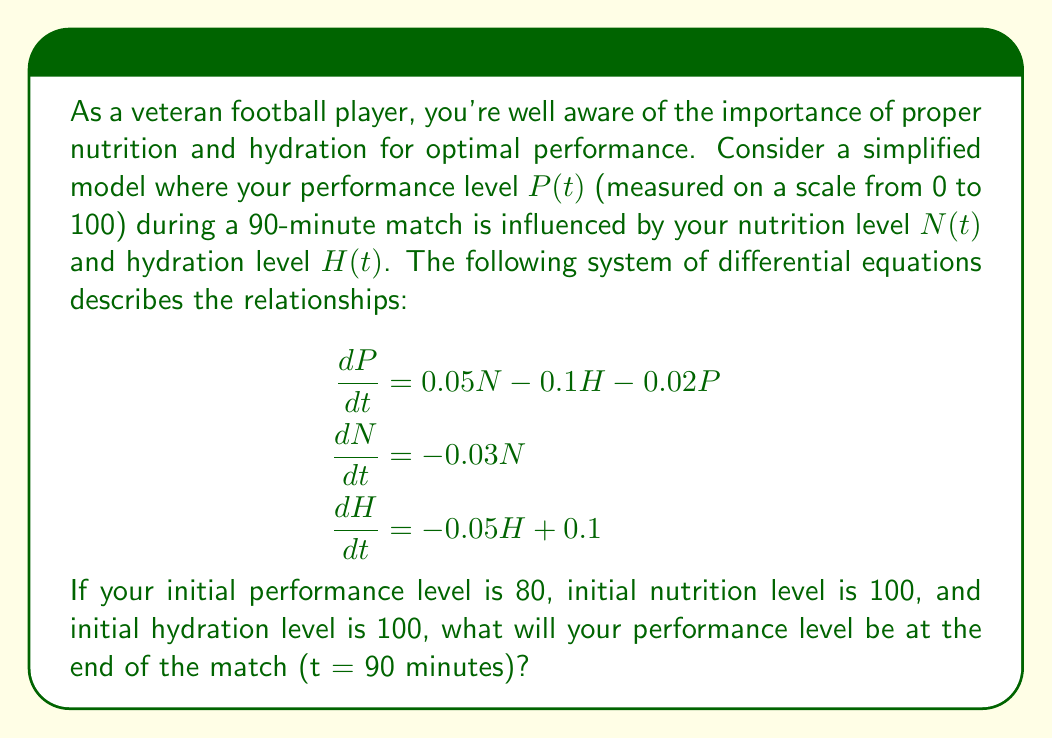What is the answer to this math problem? To solve this problem, we need to use numerical methods to approximate the solution of the system of differential equations. We'll use the Euler method with a step size of 5 minutes.

1) First, let's define our initial conditions:
   $P(0) = 80$, $N(0) = 100$, $H(0) = 100$

2) We'll use the Euler method formula:
   $y_{n+1} = y_n + h \cdot f(t_n, y_n)$
   where $h$ is the step size (5 minutes in our case)

3) For each 5-minute interval, we'll calculate:
   $P_{n+1} = P_n + 5 \cdot (0.05N_n - 0.1H_n - 0.02P_n)$
   $N_{n+1} = N_n + 5 \cdot (-0.03N_n)$
   $H_{n+1} = H_n + 5 \cdot (-0.05H_n + 0.1)$

4) Let's calculate for each time step:

   t = 0:  P = 80.00, N = 100.00, H = 100.00
   t = 5:  P = 77.00, N = 85.00,  H = 87.50
   t = 10: P = 74.56, N = 72.25,  H = 77.19
   t = 15: P = 72.59, N = 61.41,  H = 68.72
   t = 20: P = 71.00, N = 52.20,  H = 61.81
   t = 25: P = 69.73, N = 44.37,  H = 56.24
   t = 30: P = 68.71, N = 37.71,  H = 51.82
   t = 35: P = 67.90, N = 32.06,  H = 48.35
   t = 40: P = 67.27, N = 27.25,  H = 45.69
   t = 45: P = 66.78, N = 23.16,  H = 43.69
   t = 50: P = 66.40, N = 19.69,  H = 42.22
   t = 55: P = 66.12, N = 16.73,  H = 41.18
   t = 60: P = 65.91, N = 14.22,  H = 40.46
   t = 65: P = 65.76, N = 12.09,  H = 39.98
   t = 70: P = 65.65, N = 10.28,  H = 39.68
   t = 75: P = 65.57, N = 8.74,   H = 39.51
   t = 80: P = 65.51, N = 7.43,   H = 39.43
   t = 85: P = 65.47, N = 6.31,   H = 39.39
   t = 90: P = 65.44, N = 5.37,   H = 39.38

5) Therefore, at the end of the match (t = 90 minutes), the performance level is approximately 65.44.
Answer: $P(90) \approx 65.44$ 